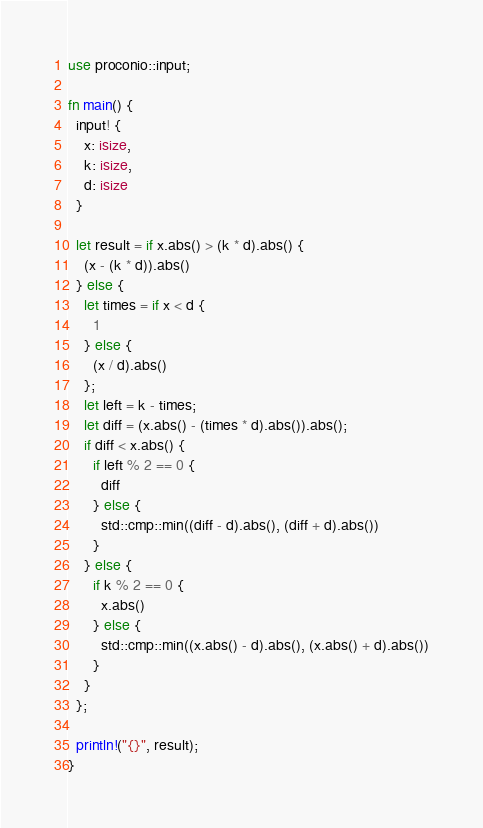<code> <loc_0><loc_0><loc_500><loc_500><_Rust_>use proconio::input;

fn main() {
  input! {
    x: isize,
    k: isize,
    d: isize
  }
  
  let result = if x.abs() > (k * d).abs() {
    (x - (k * d)).abs()
  } else {
    let times = if x < d {
      1
    } else {
      (x / d).abs()
    };
    let left = k - times;
    let diff = (x.abs() - (times * d).abs()).abs();
    if diff < x.abs() {
      if left % 2 == 0 {
        diff
      } else {
        std::cmp::min((diff - d).abs(), (diff + d).abs())
      }
    } else {
      if k % 2 == 0 {
        x.abs()
      } else {
        std::cmp::min((x.abs() - d).abs(), (x.abs() + d).abs())
      }
    }
  };
  
  println!("{}", result);
}</code> 